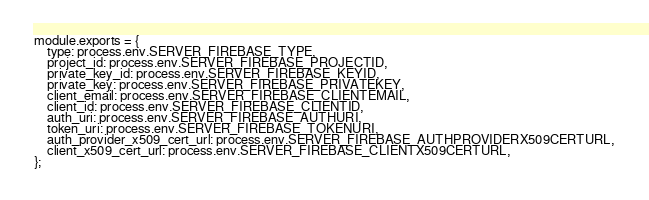<code> <loc_0><loc_0><loc_500><loc_500><_JavaScript_>module.exports = {
    type: process.env.SERVER_FIREBASE_TYPE,
    project_id: process.env.SERVER_FIREBASE_PROJECTID,
    private_key_id: process.env.SERVER_FIREBASE_KEYID,
    private_key: process.env.SERVER_FIREBASE_PRIVATEKEY,
    client_email: process.env.SERVER_FIREBASE_CLIENTEMAIL,
    client_id: process.env.SERVER_FIREBASE_CLIENTID,
    auth_uri: process.env.SERVER_FIREBASE_AUTHURI,
    token_uri: process.env.SERVER_FIREBASE_TOKENURI,
    auth_provider_x509_cert_url: process.env.SERVER_FIREBASE_AUTHPROVIDERX509CERTURL,
    client_x509_cert_url: process.env.SERVER_FIREBASE_CLIENTX509CERTURL,
};
</code> 